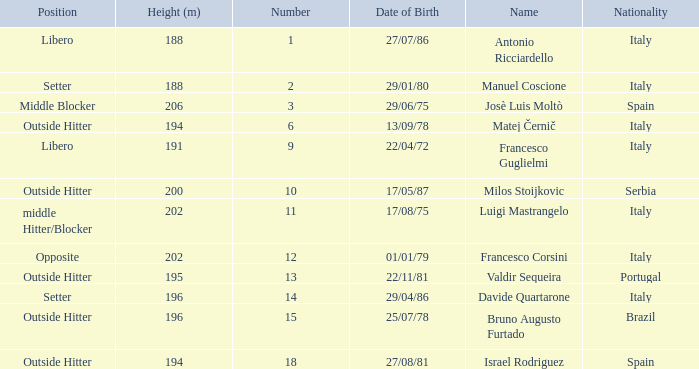Name the nationality for francesco guglielmi Italy. 